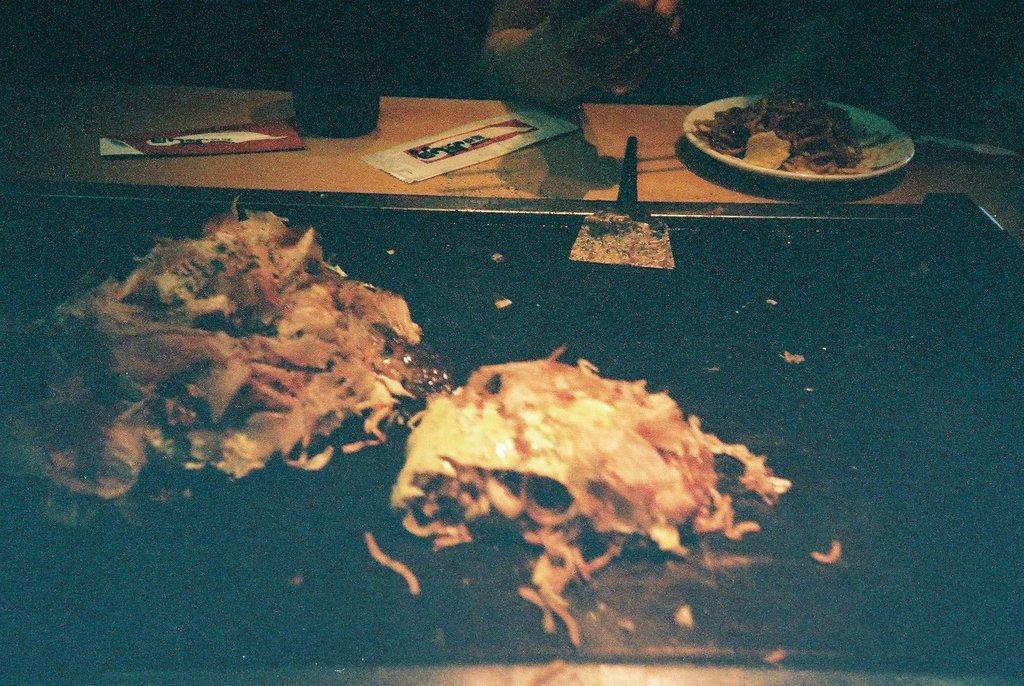Describe this image in one or two sentences. In this image there is a table, plate, food, spatula, a person's hand and objects. 